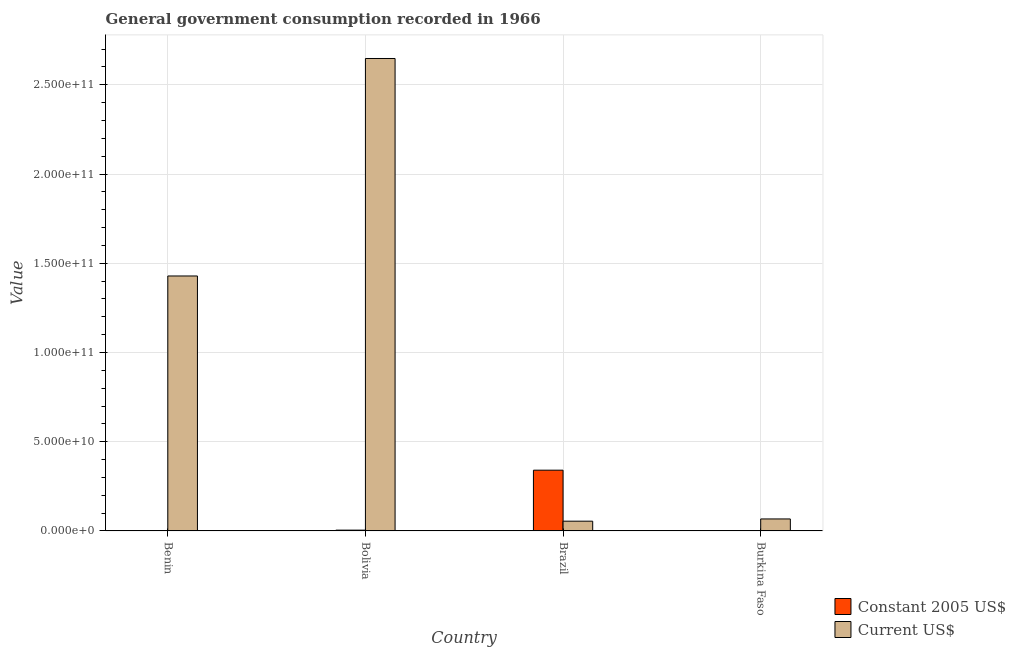How many groups of bars are there?
Offer a terse response. 4. How many bars are there on the 3rd tick from the right?
Your answer should be very brief. 2. What is the label of the 4th group of bars from the left?
Your answer should be compact. Burkina Faso. In how many cases, is the number of bars for a given country not equal to the number of legend labels?
Your answer should be compact. 0. What is the value consumed in current us$ in Bolivia?
Your answer should be compact. 2.65e+11. Across all countries, what is the maximum value consumed in constant 2005 us$?
Your answer should be very brief. 3.40e+1. Across all countries, what is the minimum value consumed in current us$?
Make the answer very short. 5.47e+09. In which country was the value consumed in current us$ minimum?
Your answer should be compact. Brazil. What is the total value consumed in current us$ in the graph?
Offer a very short reply. 4.20e+11. What is the difference between the value consumed in current us$ in Benin and that in Brazil?
Ensure brevity in your answer.  1.37e+11. What is the difference between the value consumed in constant 2005 us$ in Bolivia and the value consumed in current us$ in Benin?
Offer a terse response. -1.42e+11. What is the average value consumed in current us$ per country?
Offer a very short reply. 1.05e+11. What is the difference between the value consumed in current us$ and value consumed in constant 2005 us$ in Burkina Faso?
Your response must be concise. 6.62e+09. In how many countries, is the value consumed in constant 2005 us$ greater than 230000000000 ?
Offer a terse response. 0. What is the ratio of the value consumed in constant 2005 us$ in Benin to that in Brazil?
Your answer should be very brief. 0.01. Is the value consumed in constant 2005 us$ in Benin less than that in Brazil?
Provide a succinct answer. Yes. What is the difference between the highest and the second highest value consumed in constant 2005 us$?
Your answer should be compact. 3.36e+1. What is the difference between the highest and the lowest value consumed in constant 2005 us$?
Offer a very short reply. 3.39e+1. In how many countries, is the value consumed in constant 2005 us$ greater than the average value consumed in constant 2005 us$ taken over all countries?
Provide a succinct answer. 1. What does the 1st bar from the left in Burkina Faso represents?
Give a very brief answer. Constant 2005 US$. What does the 2nd bar from the right in Bolivia represents?
Offer a very short reply. Constant 2005 US$. What is the difference between two consecutive major ticks on the Y-axis?
Provide a short and direct response. 5.00e+1. Are the values on the major ticks of Y-axis written in scientific E-notation?
Your answer should be compact. Yes. Does the graph contain any zero values?
Your response must be concise. No. Does the graph contain grids?
Offer a very short reply. Yes. What is the title of the graph?
Provide a succinct answer. General government consumption recorded in 1966. Does "Non-solid fuel" appear as one of the legend labels in the graph?
Your response must be concise. No. What is the label or title of the Y-axis?
Provide a succinct answer. Value. What is the Value of Constant 2005 US$ in Benin?
Your answer should be compact. 1.71e+08. What is the Value in Current US$ in Benin?
Your answer should be compact. 1.43e+11. What is the Value in Constant 2005 US$ in Bolivia?
Ensure brevity in your answer.  4.54e+08. What is the Value of Current US$ in Bolivia?
Make the answer very short. 2.65e+11. What is the Value in Constant 2005 US$ in Brazil?
Give a very brief answer. 3.40e+1. What is the Value of Current US$ in Brazil?
Provide a succinct answer. 5.47e+09. What is the Value of Constant 2005 US$ in Burkina Faso?
Your answer should be compact. 1.09e+08. What is the Value of Current US$ in Burkina Faso?
Keep it short and to the point. 6.73e+09. Across all countries, what is the maximum Value in Constant 2005 US$?
Your answer should be compact. 3.40e+1. Across all countries, what is the maximum Value in Current US$?
Your response must be concise. 2.65e+11. Across all countries, what is the minimum Value of Constant 2005 US$?
Give a very brief answer. 1.09e+08. Across all countries, what is the minimum Value of Current US$?
Your answer should be compact. 5.47e+09. What is the total Value in Constant 2005 US$ in the graph?
Your answer should be compact. 3.48e+1. What is the total Value in Current US$ in the graph?
Your response must be concise. 4.20e+11. What is the difference between the Value of Constant 2005 US$ in Benin and that in Bolivia?
Keep it short and to the point. -2.84e+08. What is the difference between the Value in Current US$ in Benin and that in Bolivia?
Offer a very short reply. -1.22e+11. What is the difference between the Value in Constant 2005 US$ in Benin and that in Brazil?
Your response must be concise. -3.39e+1. What is the difference between the Value of Current US$ in Benin and that in Brazil?
Your answer should be very brief. 1.37e+11. What is the difference between the Value in Constant 2005 US$ in Benin and that in Burkina Faso?
Offer a terse response. 6.16e+07. What is the difference between the Value in Current US$ in Benin and that in Burkina Faso?
Your answer should be compact. 1.36e+11. What is the difference between the Value in Constant 2005 US$ in Bolivia and that in Brazil?
Make the answer very short. -3.36e+1. What is the difference between the Value in Current US$ in Bolivia and that in Brazil?
Offer a terse response. 2.59e+11. What is the difference between the Value of Constant 2005 US$ in Bolivia and that in Burkina Faso?
Give a very brief answer. 3.45e+08. What is the difference between the Value of Current US$ in Bolivia and that in Burkina Faso?
Give a very brief answer. 2.58e+11. What is the difference between the Value in Constant 2005 US$ in Brazil and that in Burkina Faso?
Your response must be concise. 3.39e+1. What is the difference between the Value of Current US$ in Brazil and that in Burkina Faso?
Ensure brevity in your answer.  -1.26e+09. What is the difference between the Value of Constant 2005 US$ in Benin and the Value of Current US$ in Bolivia?
Provide a succinct answer. -2.65e+11. What is the difference between the Value of Constant 2005 US$ in Benin and the Value of Current US$ in Brazil?
Your answer should be very brief. -5.30e+09. What is the difference between the Value in Constant 2005 US$ in Benin and the Value in Current US$ in Burkina Faso?
Make the answer very short. -6.55e+09. What is the difference between the Value in Constant 2005 US$ in Bolivia and the Value in Current US$ in Brazil?
Your answer should be compact. -5.01e+09. What is the difference between the Value of Constant 2005 US$ in Bolivia and the Value of Current US$ in Burkina Faso?
Keep it short and to the point. -6.27e+09. What is the difference between the Value in Constant 2005 US$ in Brazil and the Value in Current US$ in Burkina Faso?
Ensure brevity in your answer.  2.73e+1. What is the average Value of Constant 2005 US$ per country?
Make the answer very short. 8.69e+09. What is the average Value of Current US$ per country?
Provide a short and direct response. 1.05e+11. What is the difference between the Value of Constant 2005 US$ and Value of Current US$ in Benin?
Provide a short and direct response. -1.43e+11. What is the difference between the Value of Constant 2005 US$ and Value of Current US$ in Bolivia?
Provide a succinct answer. -2.64e+11. What is the difference between the Value in Constant 2005 US$ and Value in Current US$ in Brazil?
Your answer should be very brief. 2.86e+1. What is the difference between the Value of Constant 2005 US$ and Value of Current US$ in Burkina Faso?
Keep it short and to the point. -6.62e+09. What is the ratio of the Value in Constant 2005 US$ in Benin to that in Bolivia?
Offer a very short reply. 0.38. What is the ratio of the Value of Current US$ in Benin to that in Bolivia?
Make the answer very short. 0.54. What is the ratio of the Value in Constant 2005 US$ in Benin to that in Brazil?
Provide a succinct answer. 0.01. What is the ratio of the Value of Current US$ in Benin to that in Brazil?
Your answer should be very brief. 26.13. What is the ratio of the Value in Constant 2005 US$ in Benin to that in Burkina Faso?
Your answer should be very brief. 1.56. What is the ratio of the Value in Current US$ in Benin to that in Burkina Faso?
Provide a succinct answer. 21.24. What is the ratio of the Value of Constant 2005 US$ in Bolivia to that in Brazil?
Your answer should be compact. 0.01. What is the ratio of the Value of Current US$ in Bolivia to that in Brazil?
Your response must be concise. 48.42. What is the ratio of the Value of Constant 2005 US$ in Bolivia to that in Burkina Faso?
Make the answer very short. 4.17. What is the ratio of the Value in Current US$ in Bolivia to that in Burkina Faso?
Provide a short and direct response. 39.37. What is the ratio of the Value in Constant 2005 US$ in Brazil to that in Burkina Faso?
Give a very brief answer. 312.44. What is the ratio of the Value in Current US$ in Brazil to that in Burkina Faso?
Provide a short and direct response. 0.81. What is the difference between the highest and the second highest Value in Constant 2005 US$?
Your answer should be compact. 3.36e+1. What is the difference between the highest and the second highest Value in Current US$?
Make the answer very short. 1.22e+11. What is the difference between the highest and the lowest Value of Constant 2005 US$?
Make the answer very short. 3.39e+1. What is the difference between the highest and the lowest Value in Current US$?
Your answer should be compact. 2.59e+11. 